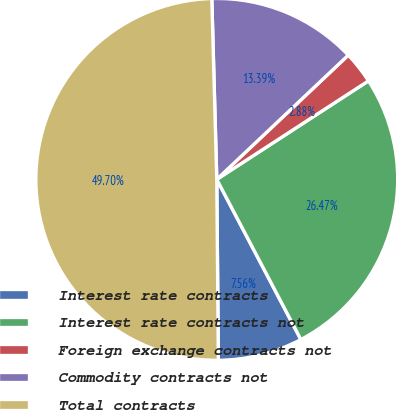Convert chart. <chart><loc_0><loc_0><loc_500><loc_500><pie_chart><fcel>Interest rate contracts<fcel>Interest rate contracts not<fcel>Foreign exchange contracts not<fcel>Commodity contracts not<fcel>Total contracts<nl><fcel>7.56%<fcel>26.47%<fcel>2.88%<fcel>13.39%<fcel>49.7%<nl></chart> 